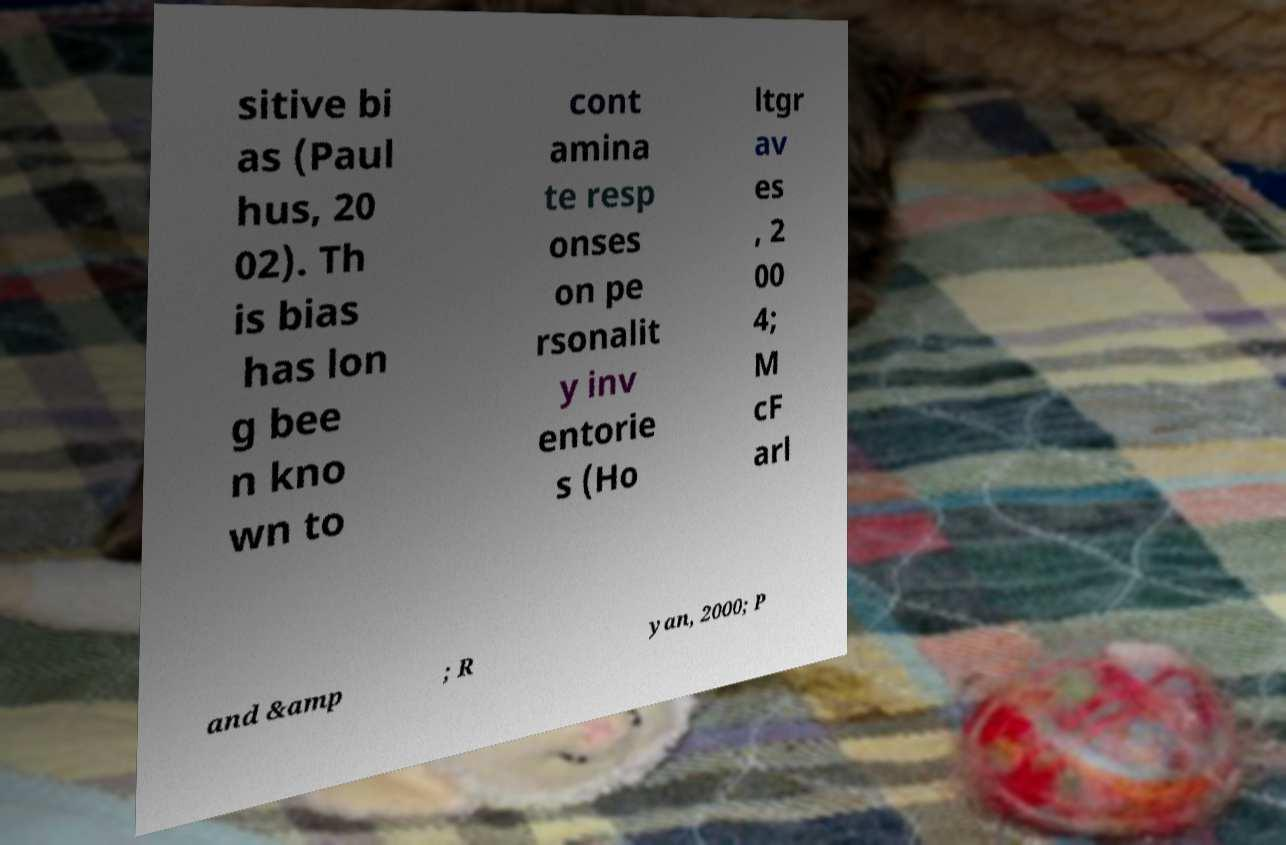Please identify and transcribe the text found in this image. sitive bi as (Paul hus, 20 02). Th is bias has lon g bee n kno wn to cont amina te resp onses on pe rsonalit y inv entorie s (Ho ltgr av es , 2 00 4; M cF arl and &amp ; R yan, 2000; P 